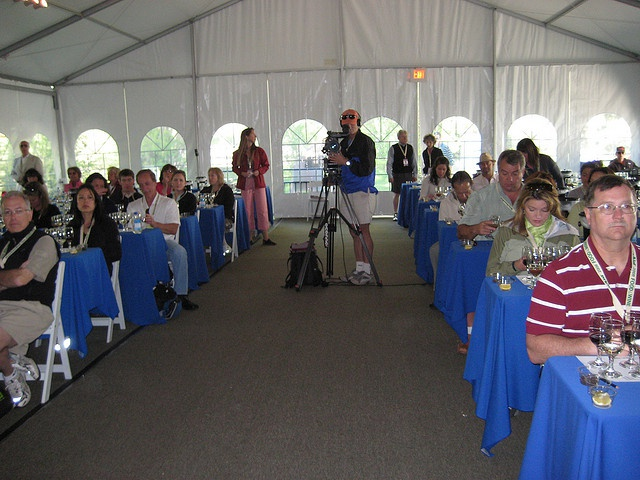Describe the objects in this image and their specific colors. I can see dining table in gray, blue, navy, and darkblue tones, people in gray, black, ivory, and darkgray tones, people in gray, brown, purple, and white tones, people in gray, black, and maroon tones, and people in gray, black, navy, and maroon tones in this image. 